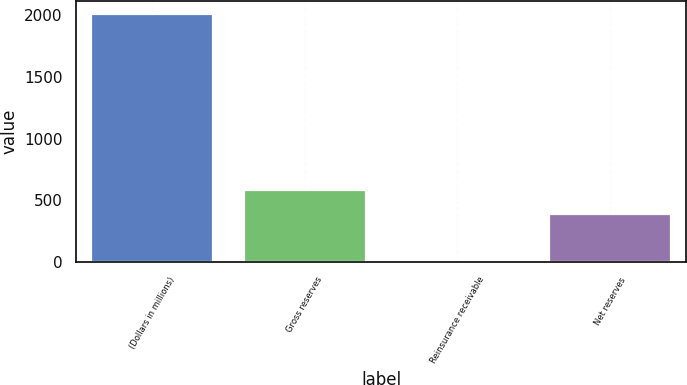Convert chart to OTSL. <chart><loc_0><loc_0><loc_500><loc_500><bar_chart><fcel>(Dollars in millions)<fcel>Gross reserves<fcel>Reinsurance receivable<fcel>Net reserves<nl><fcel>2013<fcel>586.42<fcel>15.8<fcel>386.7<nl></chart> 